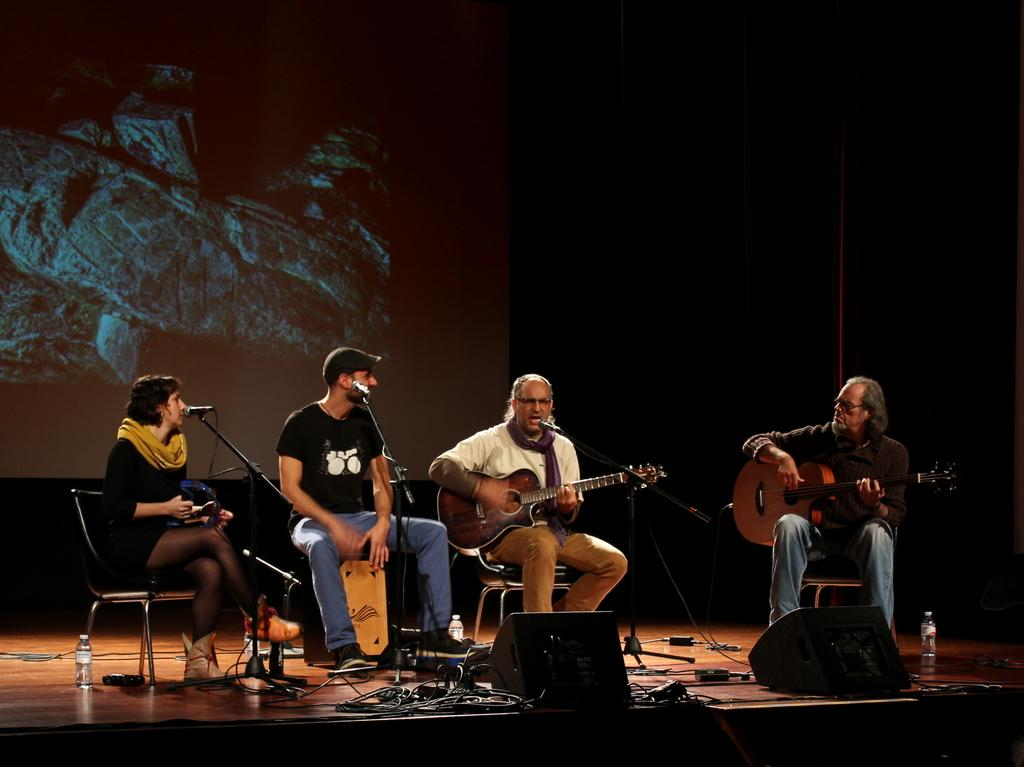How many musicians are present in the image? There are four musicians in the image. What are the musicians doing in the image? The musicians are playing music. Where are the musicians located in the image? The musicians are on a stage. What type of waves can be seen crashing on the shore in the image? There are no waves or shore present in the image; it features four musicians playing music on a stage. 